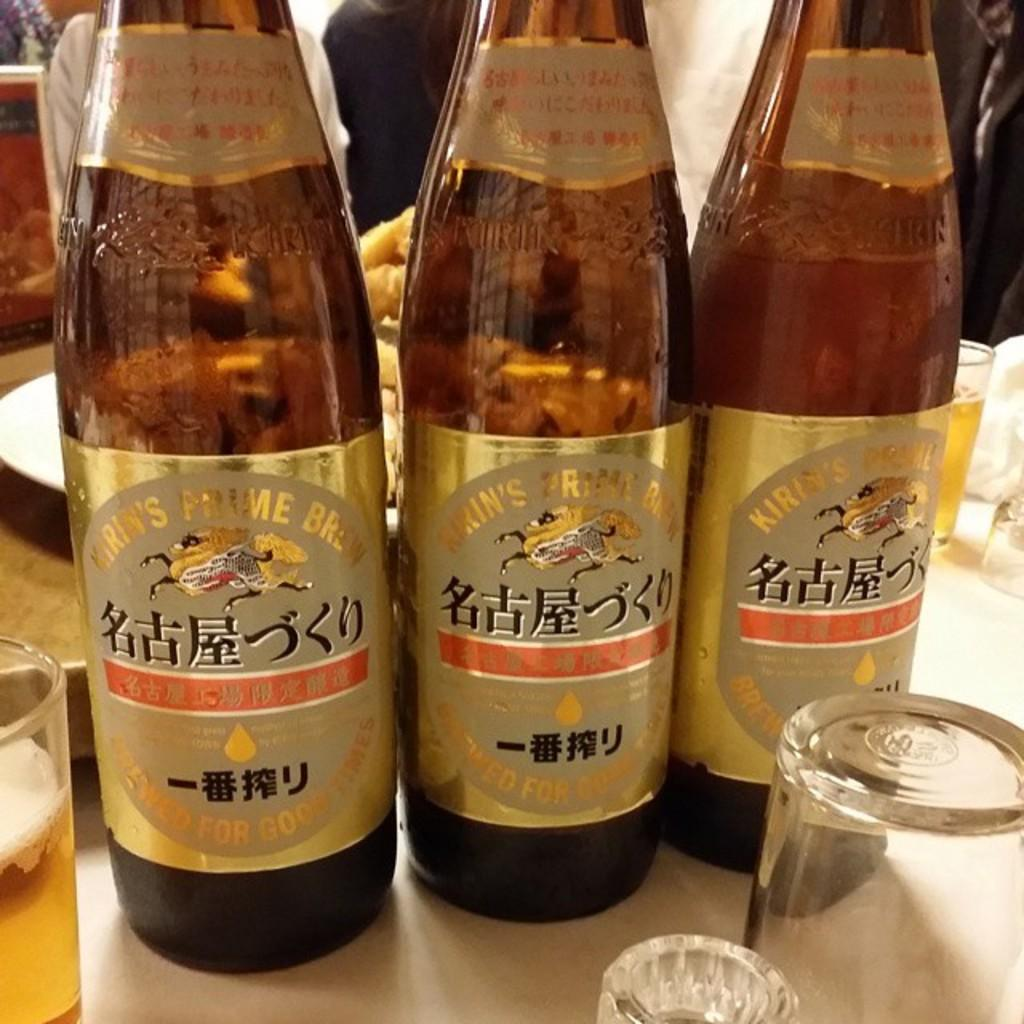<image>
Relay a brief, clear account of the picture shown. 3 beers bottles side by side branded Kirin's 